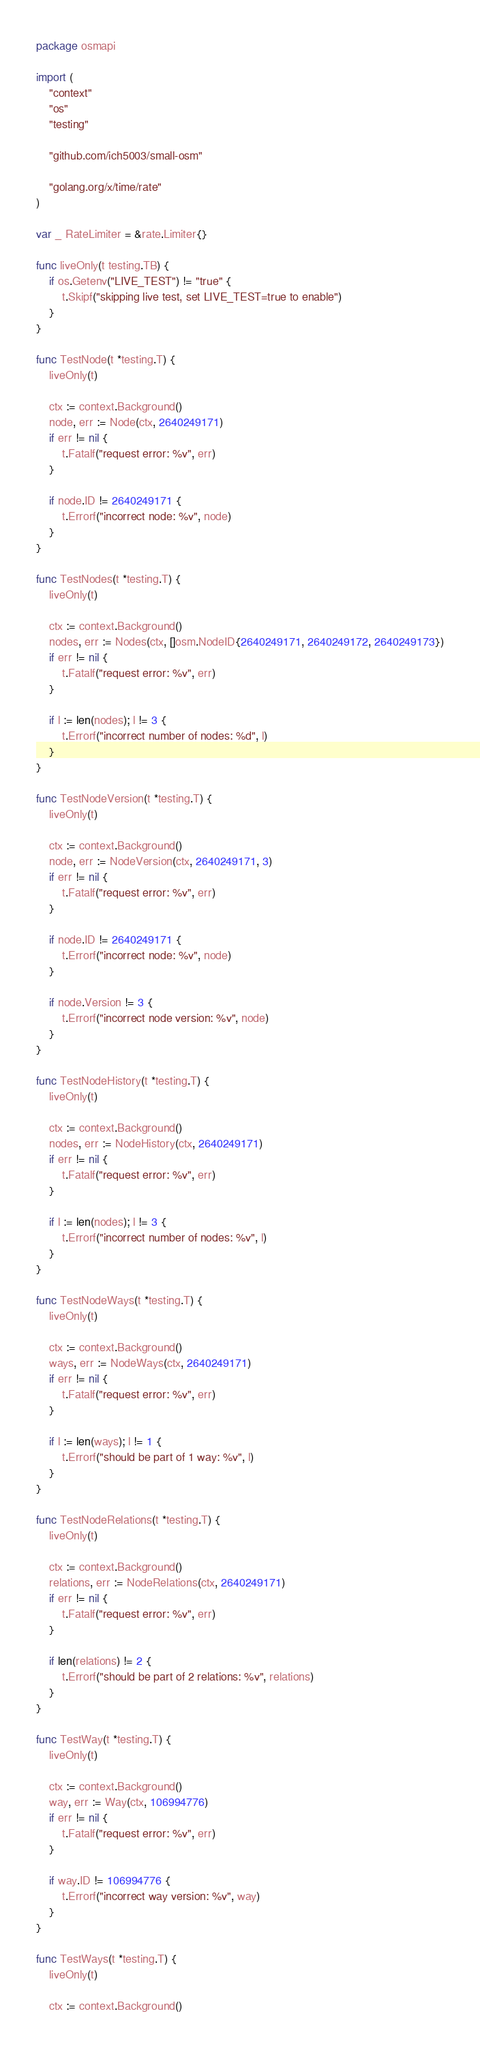Convert code to text. <code><loc_0><loc_0><loc_500><loc_500><_Go_>package osmapi

import (
	"context"
	"os"
	"testing"

	"github.com/ich5003/small-osm"

	"golang.org/x/time/rate"
)

var _ RateLimiter = &rate.Limiter{}

func liveOnly(t testing.TB) {
	if os.Getenv("LIVE_TEST") != "true" {
		t.Skipf("skipping live test, set LIVE_TEST=true to enable")
	}
}

func TestNode(t *testing.T) {
	liveOnly(t)

	ctx := context.Background()
	node, err := Node(ctx, 2640249171)
	if err != nil {
		t.Fatalf("request error: %v", err)
	}

	if node.ID != 2640249171 {
		t.Errorf("incorrect node: %v", node)
	}
}

func TestNodes(t *testing.T) {
	liveOnly(t)

	ctx := context.Background()
	nodes, err := Nodes(ctx, []osm.NodeID{2640249171, 2640249172, 2640249173})
	if err != nil {
		t.Fatalf("request error: %v", err)
	}

	if l := len(nodes); l != 3 {
		t.Errorf("incorrect number of nodes: %d", l)
	}
}

func TestNodeVersion(t *testing.T) {
	liveOnly(t)

	ctx := context.Background()
	node, err := NodeVersion(ctx, 2640249171, 3)
	if err != nil {
		t.Fatalf("request error: %v", err)
	}

	if node.ID != 2640249171 {
		t.Errorf("incorrect node: %v", node)
	}

	if node.Version != 3 {
		t.Errorf("incorrect node version: %v", node)
	}
}

func TestNodeHistory(t *testing.T) {
	liveOnly(t)

	ctx := context.Background()
	nodes, err := NodeHistory(ctx, 2640249171)
	if err != nil {
		t.Fatalf("request error: %v", err)
	}

	if l := len(nodes); l != 3 {
		t.Errorf("incorrect number of nodes: %v", l)
	}
}

func TestNodeWays(t *testing.T) {
	liveOnly(t)

	ctx := context.Background()
	ways, err := NodeWays(ctx, 2640249171)
	if err != nil {
		t.Fatalf("request error: %v", err)
	}

	if l := len(ways); l != 1 {
		t.Errorf("should be part of 1 way: %v", l)
	}
}

func TestNodeRelations(t *testing.T) {
	liveOnly(t)

	ctx := context.Background()
	relations, err := NodeRelations(ctx, 2640249171)
	if err != nil {
		t.Fatalf("request error: %v", err)
	}

	if len(relations) != 2 {
		t.Errorf("should be part of 2 relations: %v", relations)
	}
}

func TestWay(t *testing.T) {
	liveOnly(t)

	ctx := context.Background()
	way, err := Way(ctx, 106994776)
	if err != nil {
		t.Fatalf("request error: %v", err)
	}

	if way.ID != 106994776 {
		t.Errorf("incorrect way version: %v", way)
	}
}

func TestWays(t *testing.T) {
	liveOnly(t)

	ctx := context.Background()</code> 